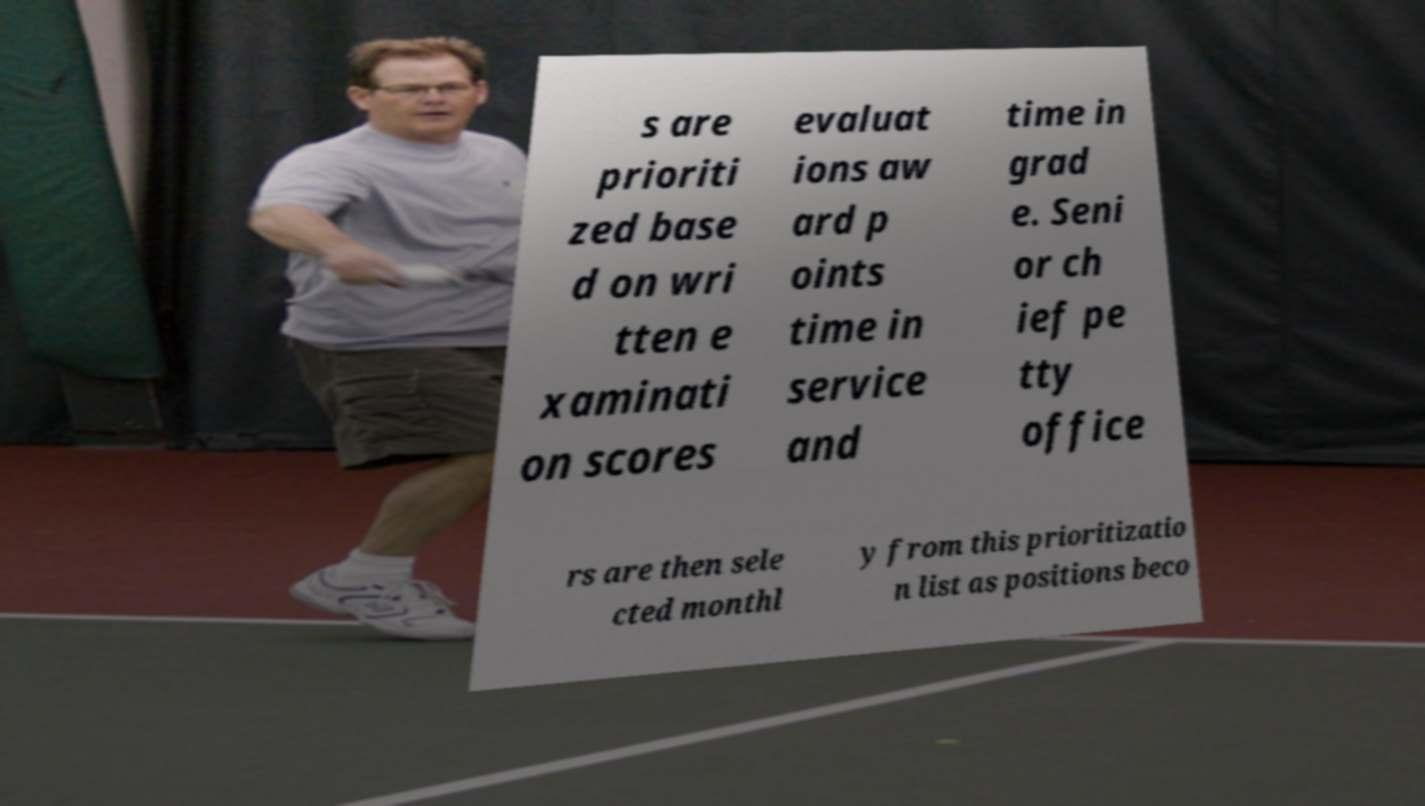Please identify and transcribe the text found in this image. s are prioriti zed base d on wri tten e xaminati on scores evaluat ions aw ard p oints time in service and time in grad e. Seni or ch ief pe tty office rs are then sele cted monthl y from this prioritizatio n list as positions beco 